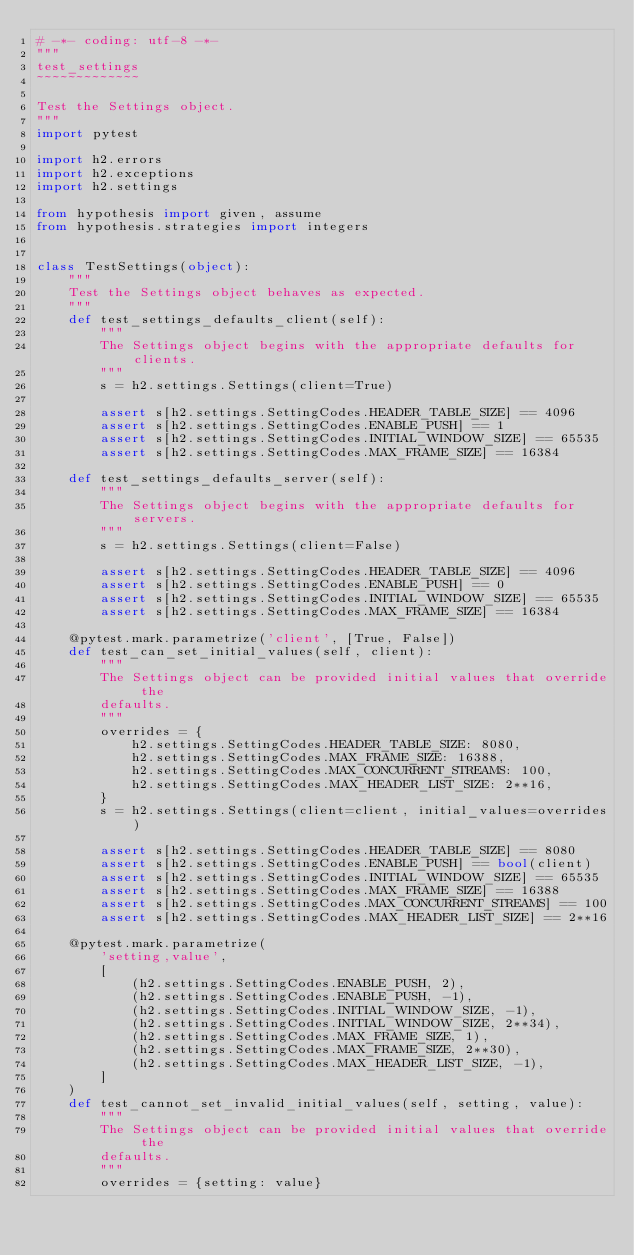<code> <loc_0><loc_0><loc_500><loc_500><_Python_># -*- coding: utf-8 -*-
"""
test_settings
~~~~~~~~~~~~~

Test the Settings object.
"""
import pytest

import h2.errors
import h2.exceptions
import h2.settings

from hypothesis import given, assume
from hypothesis.strategies import integers


class TestSettings(object):
    """
    Test the Settings object behaves as expected.
    """
    def test_settings_defaults_client(self):
        """
        The Settings object begins with the appropriate defaults for clients.
        """
        s = h2.settings.Settings(client=True)

        assert s[h2.settings.SettingCodes.HEADER_TABLE_SIZE] == 4096
        assert s[h2.settings.SettingCodes.ENABLE_PUSH] == 1
        assert s[h2.settings.SettingCodes.INITIAL_WINDOW_SIZE] == 65535
        assert s[h2.settings.SettingCodes.MAX_FRAME_SIZE] == 16384

    def test_settings_defaults_server(self):
        """
        The Settings object begins with the appropriate defaults for servers.
        """
        s = h2.settings.Settings(client=False)

        assert s[h2.settings.SettingCodes.HEADER_TABLE_SIZE] == 4096
        assert s[h2.settings.SettingCodes.ENABLE_PUSH] == 0
        assert s[h2.settings.SettingCodes.INITIAL_WINDOW_SIZE] == 65535
        assert s[h2.settings.SettingCodes.MAX_FRAME_SIZE] == 16384

    @pytest.mark.parametrize('client', [True, False])
    def test_can_set_initial_values(self, client):
        """
        The Settings object can be provided initial values that override the
        defaults.
        """
        overrides = {
            h2.settings.SettingCodes.HEADER_TABLE_SIZE: 8080,
            h2.settings.SettingCodes.MAX_FRAME_SIZE: 16388,
            h2.settings.SettingCodes.MAX_CONCURRENT_STREAMS: 100,
            h2.settings.SettingCodes.MAX_HEADER_LIST_SIZE: 2**16,
        }
        s = h2.settings.Settings(client=client, initial_values=overrides)

        assert s[h2.settings.SettingCodes.HEADER_TABLE_SIZE] == 8080
        assert s[h2.settings.SettingCodes.ENABLE_PUSH] == bool(client)
        assert s[h2.settings.SettingCodes.INITIAL_WINDOW_SIZE] == 65535
        assert s[h2.settings.SettingCodes.MAX_FRAME_SIZE] == 16388
        assert s[h2.settings.SettingCodes.MAX_CONCURRENT_STREAMS] == 100
        assert s[h2.settings.SettingCodes.MAX_HEADER_LIST_SIZE] == 2**16

    @pytest.mark.parametrize(
        'setting,value',
        [
            (h2.settings.SettingCodes.ENABLE_PUSH, 2),
            (h2.settings.SettingCodes.ENABLE_PUSH, -1),
            (h2.settings.SettingCodes.INITIAL_WINDOW_SIZE, -1),
            (h2.settings.SettingCodes.INITIAL_WINDOW_SIZE, 2**34),
            (h2.settings.SettingCodes.MAX_FRAME_SIZE, 1),
            (h2.settings.SettingCodes.MAX_FRAME_SIZE, 2**30),
            (h2.settings.SettingCodes.MAX_HEADER_LIST_SIZE, -1),
        ]
    )
    def test_cannot_set_invalid_initial_values(self, setting, value):
        """
        The Settings object can be provided initial values that override the
        defaults.
        """
        overrides = {setting: value}
</code> 